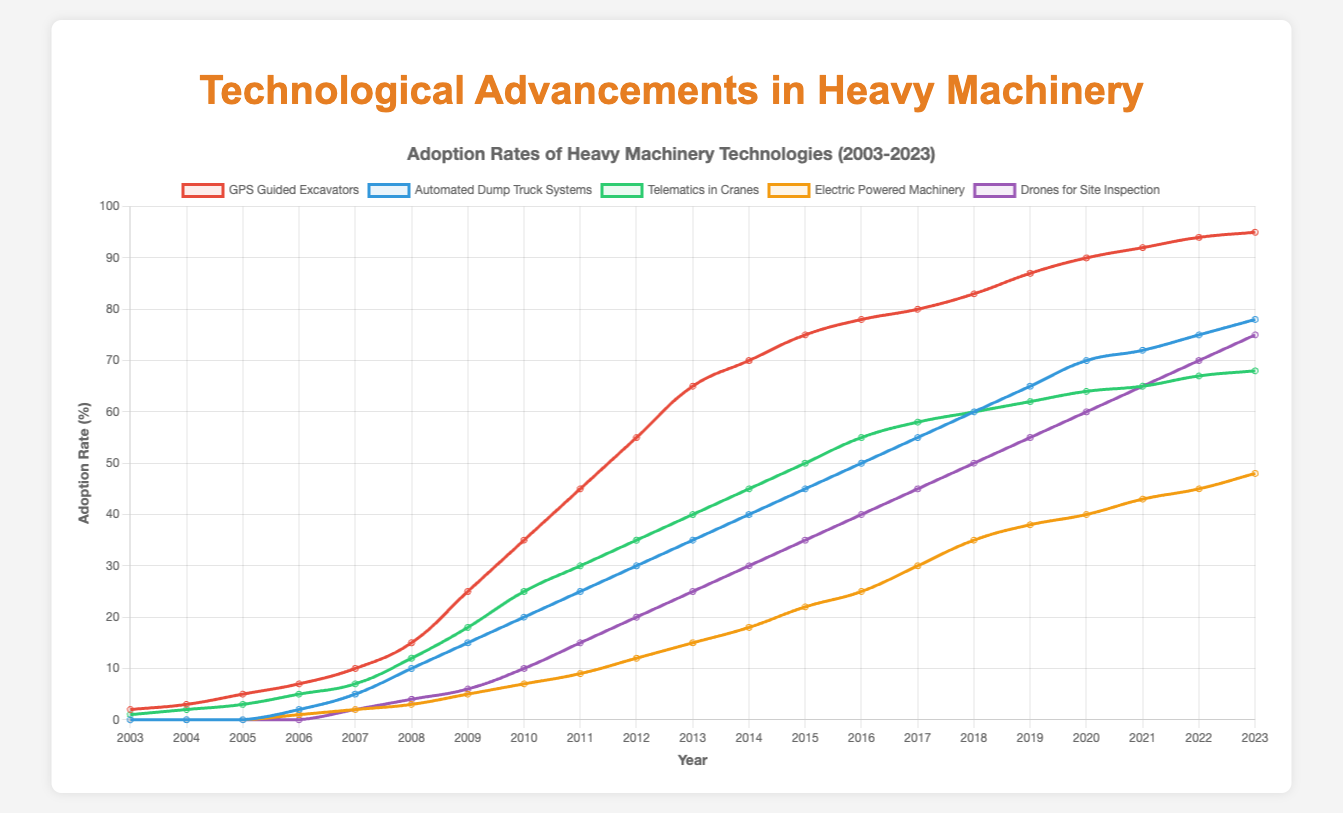What is the highest adoption rate for GPS Guided Excavators, and in which year does it occur? The peak value for GPS Guided Excavators appears at the 2023 data point. By examining the chart, we can see that the highest adoption rate for GPS Guided Excavators in the graph is 95%.
Answer: 95% in 2023 How does the adoption rate of Automated Dump Truck Systems in 2010 compare to Telematics in Cranes in the same year? In 2010, the adoption rate for Automated Dump Truck Systems is represented by a point on the graph at approximately 25%, while Telematics in Cranes is at 30%. Thus, Telematics in Cranes has a higher adoption rate.
Answer: Telematics in Cranes is higher at 30% compared to 25% for Automated Dump Truck Systems Over the time span of 2008 to 2013, which technology shows the steepest increase in adoption? To determine the steepest increase, we look at the slope of the lines between 2008 and 2013 for each technology. GPS Guided Excavators show an increase from 15% to 65%, which is an increase of 50 percentage points over 5 years. This is the steepest increase among all technologies.
Answer: GPS Guided Excavators Which technology showed no adoption before the year 2008? By examining the chart lines, we see that both Automated Dump Truck Systems and Electric Powered Machinery start at 0% until 2008. Additionally, Drones for Site Inspection and Electric Powered Machinery also show no adoption before 2008 based on the flat lines at the initial years.
Answer: Automated Dump Truck Systems, Electric Powered Machinery, Drones for Site Inspection What is the average adoption rate of Telematics in Cranes from 2018 to 2021? Observing the values from 2018 to 2021 for Telematics in Cranes, we see values of 60%, 62%, 64%, and 65%. Adding these up: 60 + 62 + 64 + 65 = 251. We then divide by the 4 years to get the average: 251 / 4 = 62.75%.
Answer: 62.75% Which technologies had the same adoption rate in the year 2023? Referring to the year 2023 on the chart, we can see the adoption rates for different technologies. Telematics in Cranes and Electric Powered Machinery intersect at the same rate of 68%.
Answer: Telematics in Cranes and Electric Powered Machinery at 68% How many years did it take for Drones for Site Inspection to reach an adoption rate above 50%? Drones for Site Inspection reached an adoption rate above 50% in 2018, starting from 0% in 2007. Counting the years from 2007 to 2018 gives us 11 years.
Answer: 11 years For the year 2020, list the technologies in descending order of their adoption rates. Reviewing the chart at 2020, the adoption rates are as follows: GPS Guided Excavators (90%), Automated Dump Truck Systems (70%), Telematics in Cranes (64%), Drones for Site Inspection (60%), Electric Powered Machinery (40%). Sorting these in descending order gives: GPS Guided Excavators > Automated Dump Truck Systems > Telematics in Cranes > Drones for Site Inspection > Electric Powered Machinery.
Answer: GPS Guided Excavators > Automated Dump Truck Systems > Telematics in Cranes > Drones for Site Inspection > Electric Powered Machinery What is the difference in the adoption rate of GPS Guided Excavators between 2003 and 2023? In 2003, the adoption rate for GPS Guided Excavators is 3%, and in 2023 it is 95%. Therefore, the difference is 95% - 3% = 92%.
Answer: 92% 